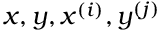Convert formula to latex. <formula><loc_0><loc_0><loc_500><loc_500>x , y , x ^ { ( i ) } , y ^ { ( j ) }</formula> 